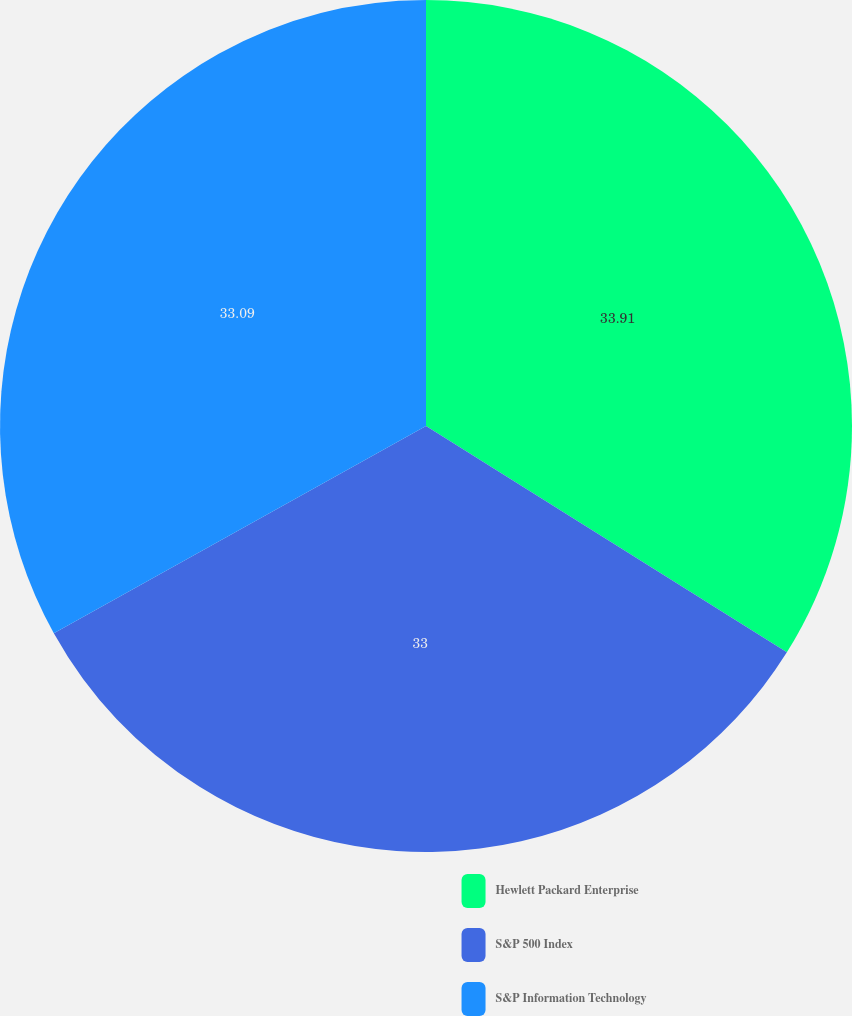<chart> <loc_0><loc_0><loc_500><loc_500><pie_chart><fcel>Hewlett Packard Enterprise<fcel>S&P 500 Index<fcel>S&P Information Technology<nl><fcel>33.92%<fcel>33.0%<fcel>33.09%<nl></chart> 